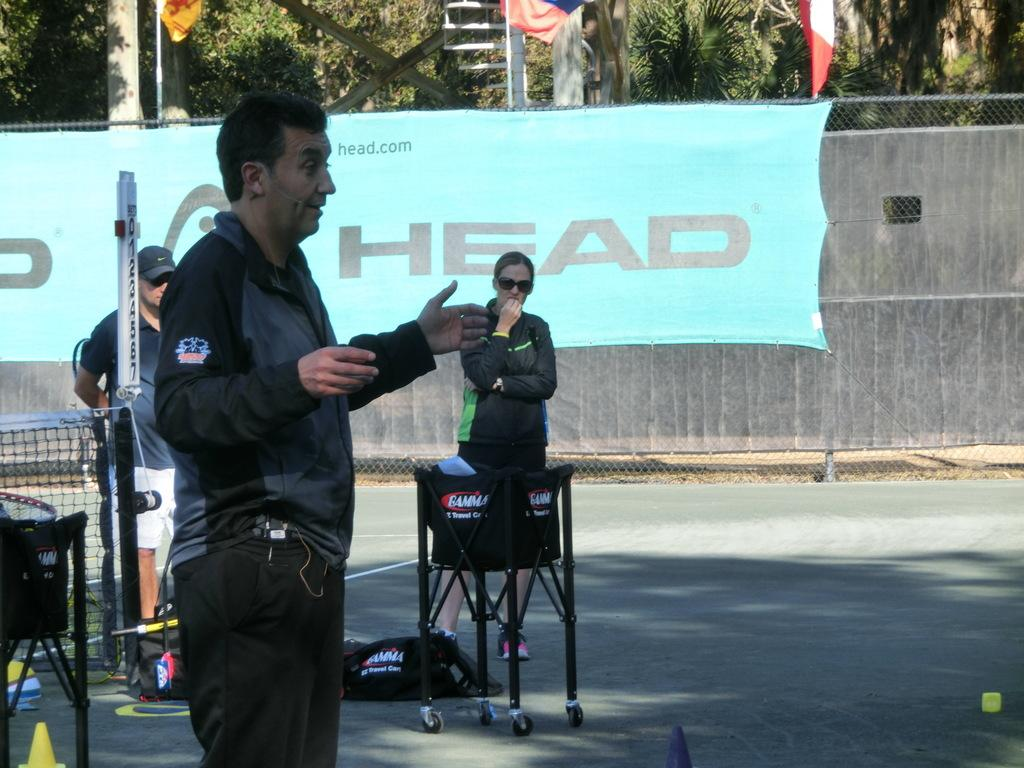What is the main subject of the image? A man is standing in the image. What else can be seen in the image besides the man? There are people standing on the road, a net, trees, and a banner in the image. What type of button is the man wearing on his shirt in the image? There is no button visible on the man's shirt in the image. How does the man express regret in the image? There is no indication of regret in the image, as it only shows a man standing with other elements present. 